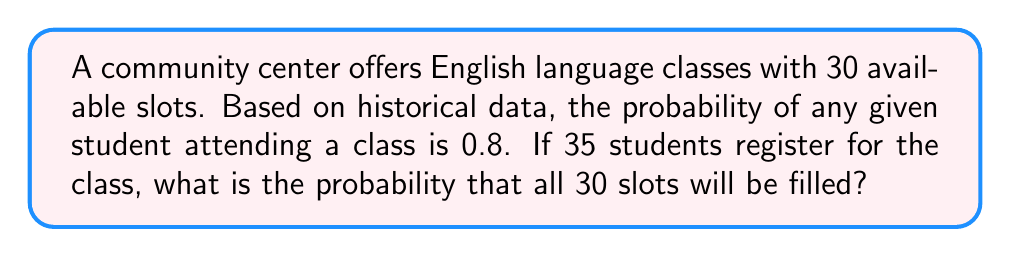Provide a solution to this math problem. To solve this problem, we need to use the binomial probability distribution. We want to find the probability of 30 or more students attending out of 35 registered students.

Let's break it down step-by-step:

1) The probability of success (a student attending) is $p = 0.8$
2) The probability of failure (a student not attending) is $q = 1 - p = 0.2$
3) The number of trials (registered students) is $n = 35$
4) The number of successes we want (filled slots) is $k \geq 30$

We need to calculate:

$$P(X \geq 30) = P(X = 30) + P(X = 31) + P(X = 32) + P(X = 33) + P(X = 34) + P(X = 35)$$

Using the binomial probability formula:

$$P(X = k) = \binom{n}{k} p^k q^{n-k}$$

For each value of $k$ from 30 to 35, we calculate:

$$P(X = 30) = \binom{35}{30} (0.8)^{30} (0.2)^5 = 0.1498$$
$$P(X = 31) = \binom{35}{31} (0.8)^{31} (0.2)^4 = 0.2076$$
$$P(X = 32) = \binom{35}{32} (0.8)^{32} (0.2)^3 = 0.2184$$
$$P(X = 33) = \binom{35}{33} (0.8)^{33} (0.2)^2 = 0.1695$$
$$P(X = 34) = \binom{35}{34} (0.8)^{34} (0.2)^1 = 0.0919$$
$$P(X = 35) = \binom{35}{35} (0.8)^{35} (0.2)^0 = 0.0272$$

Now, we sum these probabilities:

$$P(X \geq 30) = 0.1498 + 0.2076 + 0.2184 + 0.1695 + 0.0919 + 0.0272 = 0.8644$$

Therefore, the probability of filling all 30 slots is approximately 0.8644 or 86.44%.
Answer: $0.8644$ or $86.44\%$ 